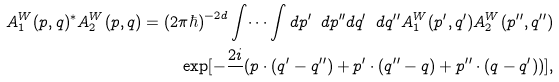<formula> <loc_0><loc_0><loc_500><loc_500>A ^ { W } _ { 1 } ( { p } , { q } ) ^ { * } A ^ { W } _ { 2 } ( { p } , { q } ) = ( 2 \pi \hbar { ) } ^ { - 2 d } \int \dots \int d { p } ^ { \prime } \ d { p } ^ { \prime \prime } d { q } ^ { \prime } \ d { q } ^ { \prime \prime } A ^ { W } _ { 1 } ( { p } ^ { \prime } , { q } ^ { \prime } ) A ^ { W } _ { 2 } ( { p } ^ { \prime \prime } , { q } ^ { \prime \prime } ) \\ \exp [ - \frac { 2 i } { } ( { p } \cdot ( { q } ^ { \prime } - { q } ^ { \prime \prime } ) + { p } ^ { \prime } \cdot ( { q } ^ { \prime \prime } - { q } ) + { p } ^ { \prime \prime } \cdot ( { q } - { q } ^ { \prime } ) ) ] , \\</formula> 